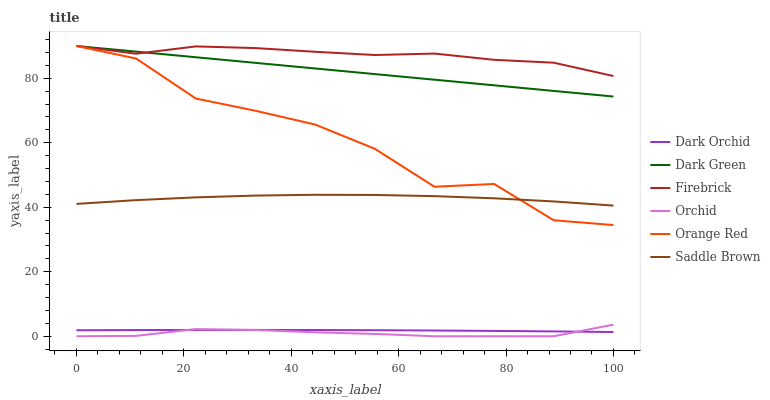Does Orchid have the minimum area under the curve?
Answer yes or no. Yes. Does Firebrick have the maximum area under the curve?
Answer yes or no. Yes. Does Dark Orchid have the minimum area under the curve?
Answer yes or no. No. Does Dark Orchid have the maximum area under the curve?
Answer yes or no. No. Is Dark Green the smoothest?
Answer yes or no. Yes. Is Orange Red the roughest?
Answer yes or no. Yes. Is Dark Orchid the smoothest?
Answer yes or no. No. Is Dark Orchid the roughest?
Answer yes or no. No. Does Orchid have the lowest value?
Answer yes or no. Yes. Does Dark Orchid have the lowest value?
Answer yes or no. No. Does Dark Green have the highest value?
Answer yes or no. Yes. Does Dark Orchid have the highest value?
Answer yes or no. No. Is Orchid less than Dark Green?
Answer yes or no. Yes. Is Saddle Brown greater than Orchid?
Answer yes or no. Yes. Does Dark Green intersect Orange Red?
Answer yes or no. Yes. Is Dark Green less than Orange Red?
Answer yes or no. No. Is Dark Green greater than Orange Red?
Answer yes or no. No. Does Orchid intersect Dark Green?
Answer yes or no. No. 